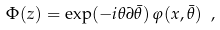Convert formula to latex. <formula><loc_0><loc_0><loc_500><loc_500>\Phi ( z ) = \exp ( - i \theta \partial \bar { \theta } ) \, \varphi ( x , \bar { \theta } ) \ ,</formula> 